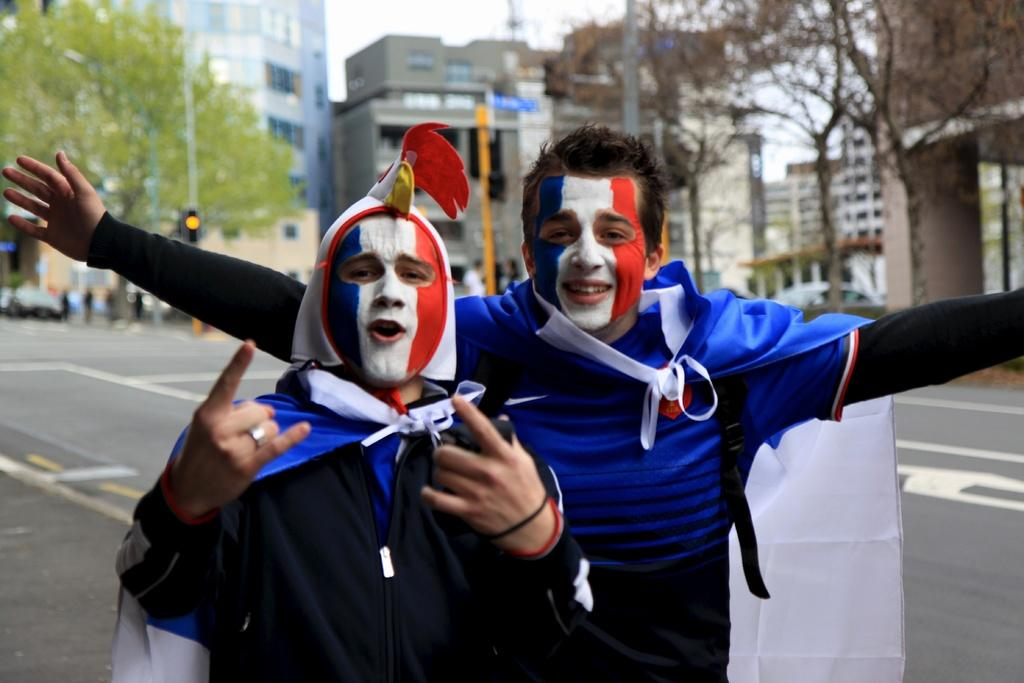What is unique about the appearance of the two persons in the image? The two persons have paintings on their faces. What can be seen in the background of the image? There are vehicles, a road, poles, buildings, trees, and the sky visible in the background. What type of pest can be seen crawling on the dad's shoulder in the image? There is no dad present in the image, and no pests are visible on anyone's shoulder. 